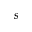<formula> <loc_0><loc_0><loc_500><loc_500>s</formula> 